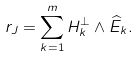Convert formula to latex. <formula><loc_0><loc_0><loc_500><loc_500>r _ { J } = \sum _ { k = 1 } ^ { m } H _ { k } ^ { \perp } \wedge \widehat { E } _ { k } .</formula> 